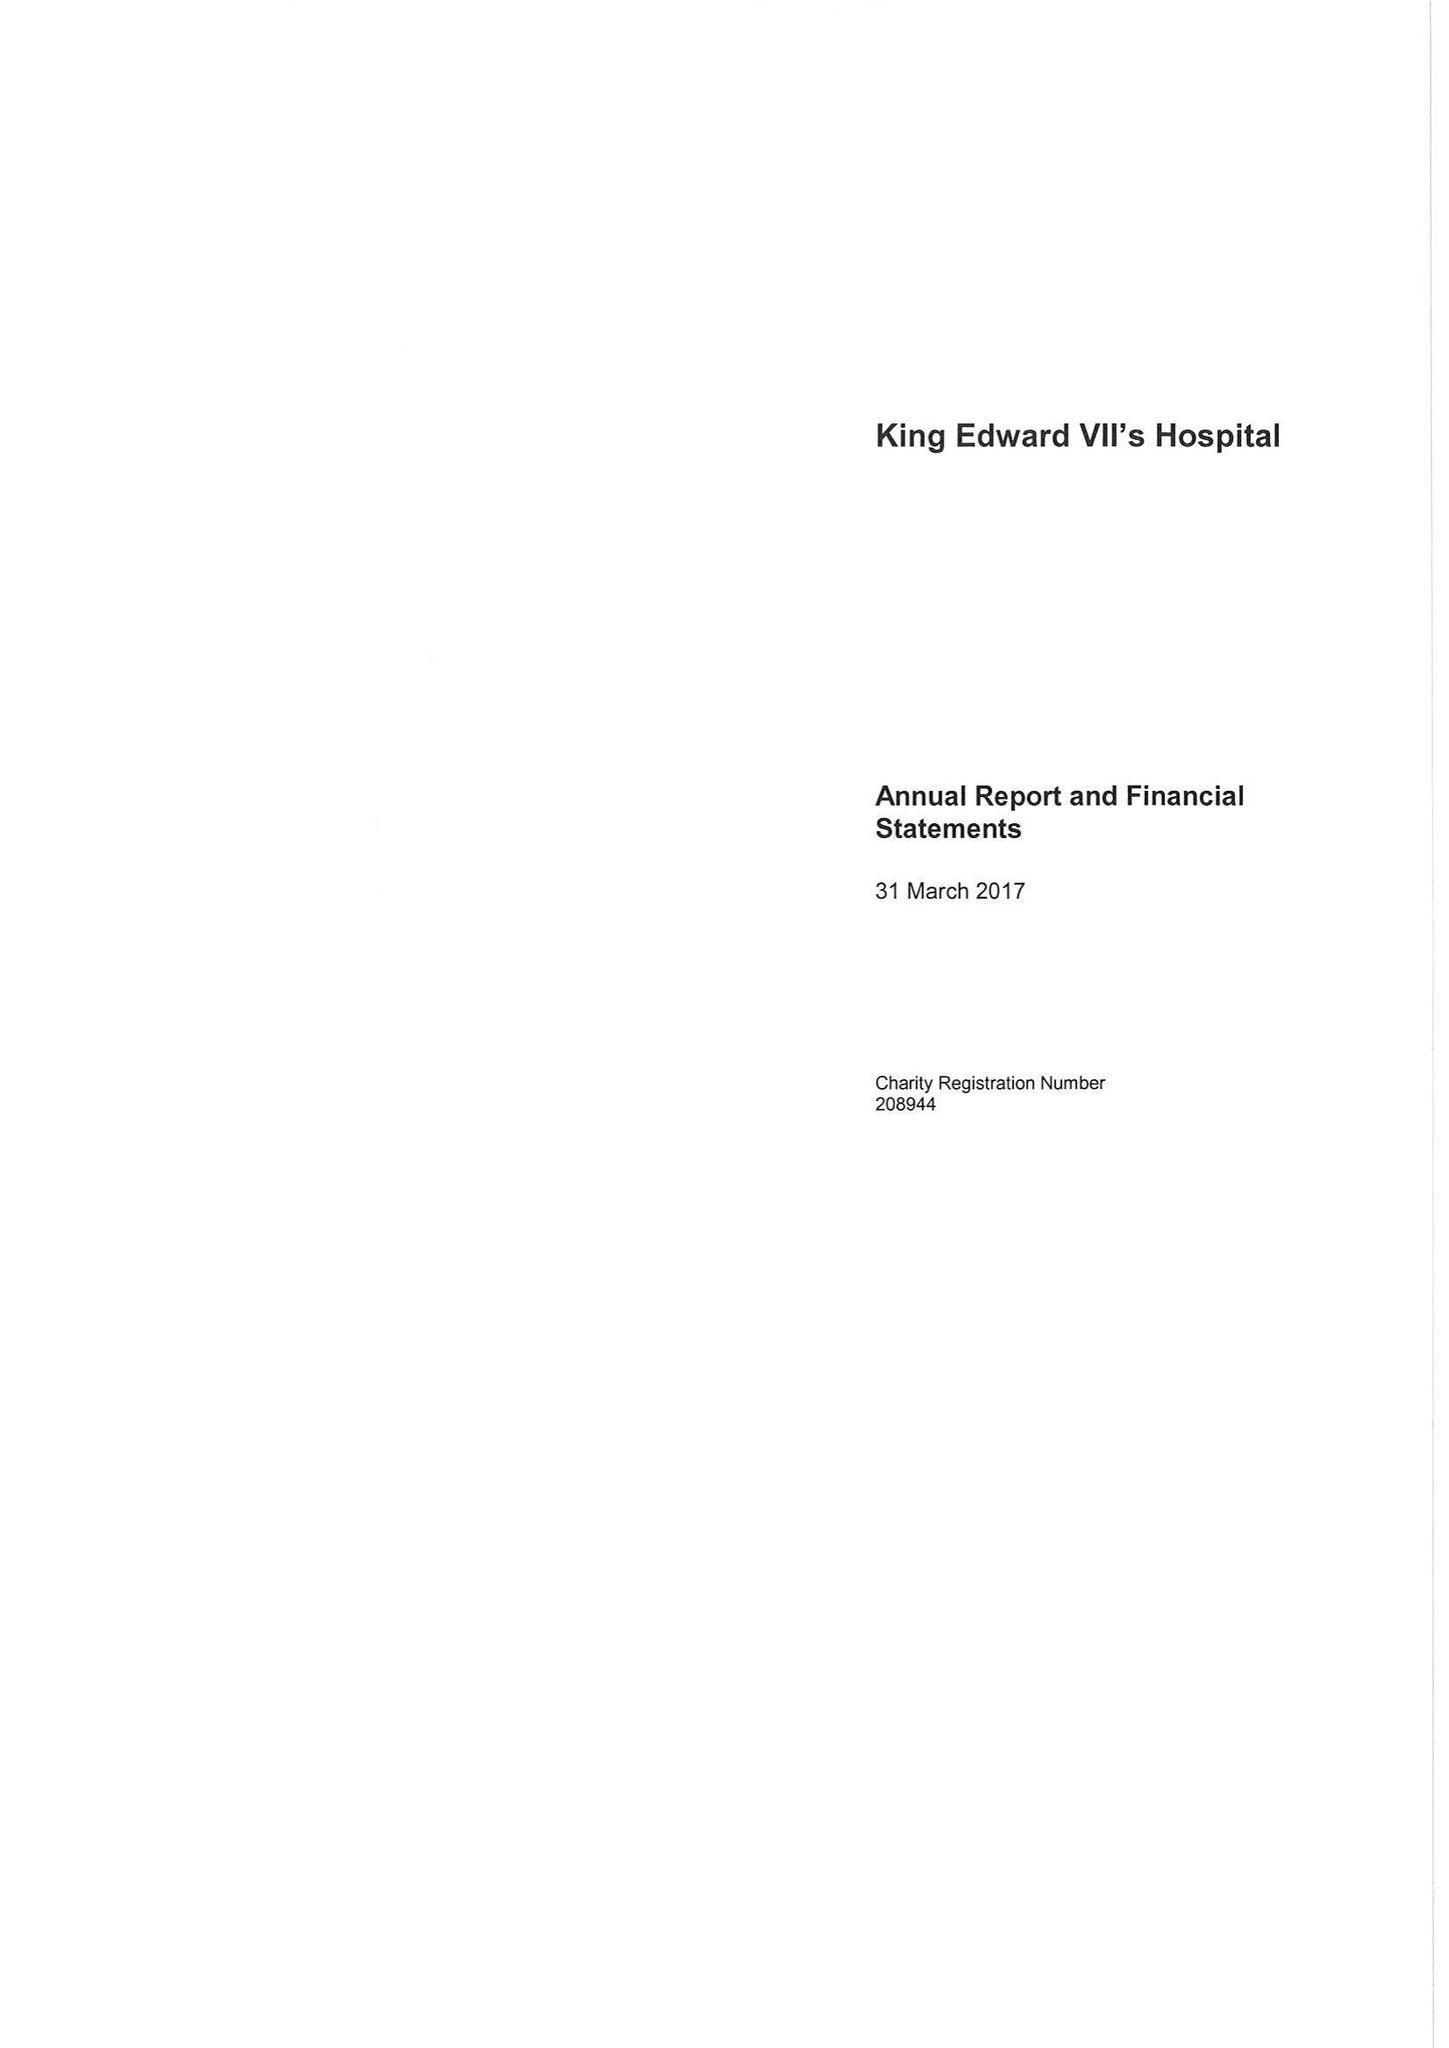What is the value for the charity_number?
Answer the question using a single word or phrase. 208944 